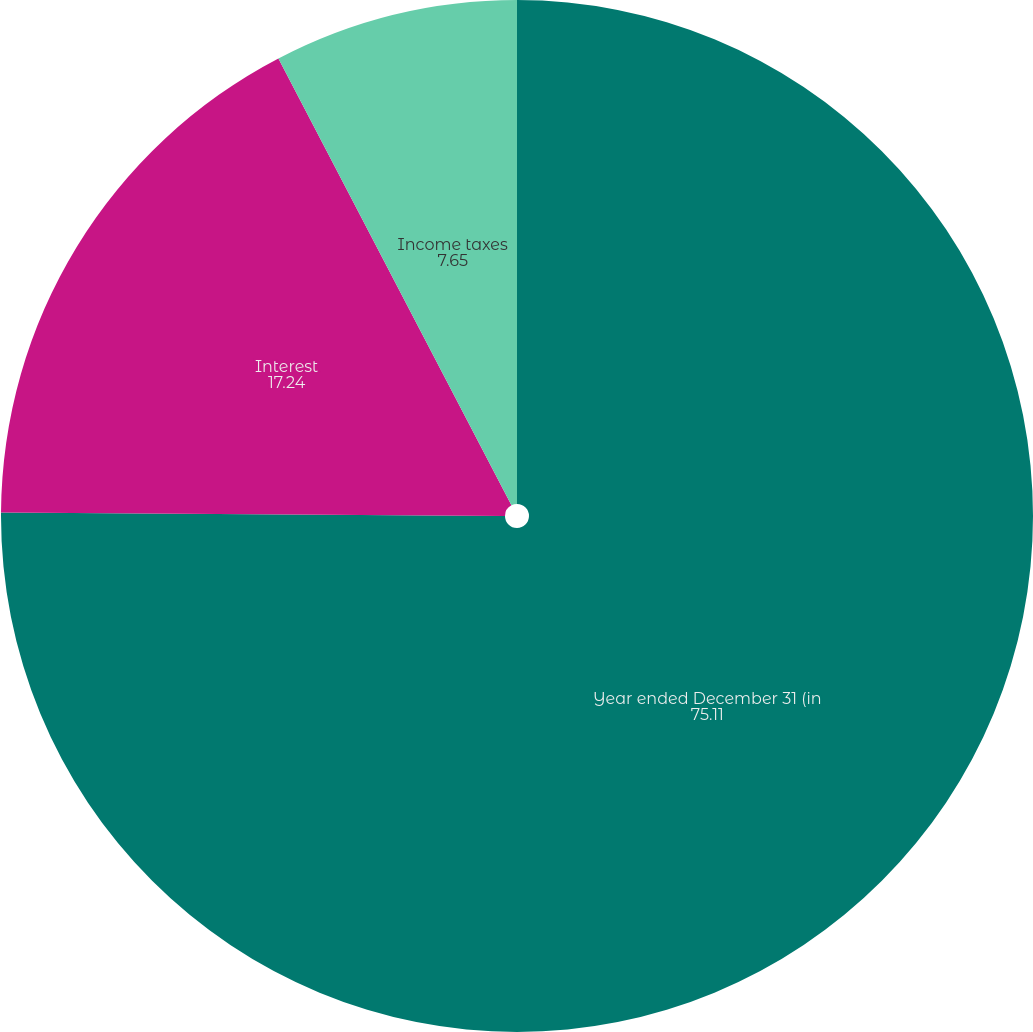<chart> <loc_0><loc_0><loc_500><loc_500><pie_chart><fcel>Year ended December 31 (in<fcel>Interest<fcel>Income taxes<nl><fcel>75.11%<fcel>17.24%<fcel>7.65%<nl></chart> 